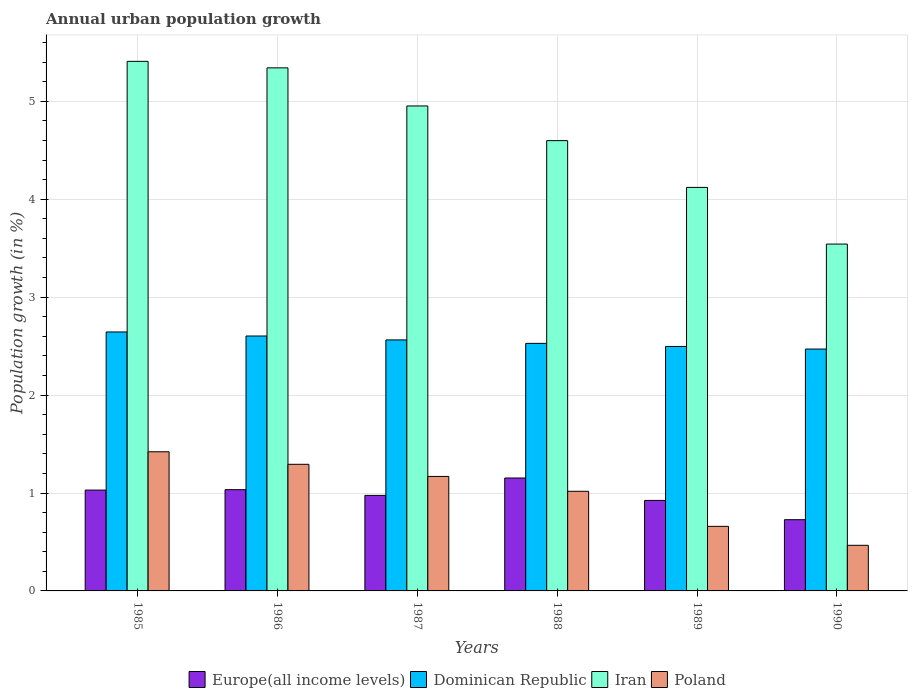How many different coloured bars are there?
Your answer should be compact. 4. How many groups of bars are there?
Your response must be concise. 6. Are the number of bars per tick equal to the number of legend labels?
Ensure brevity in your answer.  Yes. Are the number of bars on each tick of the X-axis equal?
Ensure brevity in your answer.  Yes. How many bars are there on the 3rd tick from the left?
Your answer should be compact. 4. What is the label of the 3rd group of bars from the left?
Make the answer very short. 1987. What is the percentage of urban population growth in Poland in 1988?
Your answer should be very brief. 1.02. Across all years, what is the maximum percentage of urban population growth in Poland?
Provide a short and direct response. 1.42. Across all years, what is the minimum percentage of urban population growth in Dominican Republic?
Make the answer very short. 2.47. In which year was the percentage of urban population growth in Iran minimum?
Provide a short and direct response. 1990. What is the total percentage of urban population growth in Poland in the graph?
Give a very brief answer. 6.03. What is the difference between the percentage of urban population growth in Dominican Republic in 1985 and that in 1990?
Ensure brevity in your answer.  0.17. What is the difference between the percentage of urban population growth in Poland in 1985 and the percentage of urban population growth in Iran in 1990?
Offer a terse response. -2.12. What is the average percentage of urban population growth in Dominican Republic per year?
Your response must be concise. 2.55. In the year 1989, what is the difference between the percentage of urban population growth in Dominican Republic and percentage of urban population growth in Europe(all income levels)?
Offer a very short reply. 1.57. In how many years, is the percentage of urban population growth in Europe(all income levels) greater than 2.4 %?
Your answer should be very brief. 0. What is the ratio of the percentage of urban population growth in Poland in 1987 to that in 1988?
Offer a very short reply. 1.15. Is the difference between the percentage of urban population growth in Dominican Republic in 1987 and 1990 greater than the difference between the percentage of urban population growth in Europe(all income levels) in 1987 and 1990?
Give a very brief answer. No. What is the difference between the highest and the second highest percentage of urban population growth in Iran?
Your answer should be compact. 0.07. What is the difference between the highest and the lowest percentage of urban population growth in Dominican Republic?
Ensure brevity in your answer.  0.17. Is the sum of the percentage of urban population growth in Iran in 1985 and 1989 greater than the maximum percentage of urban population growth in Europe(all income levels) across all years?
Keep it short and to the point. Yes. What does the 3rd bar from the right in 1989 represents?
Your answer should be compact. Dominican Republic. Is it the case that in every year, the sum of the percentage of urban population growth in Europe(all income levels) and percentage of urban population growth in Iran is greater than the percentage of urban population growth in Poland?
Keep it short and to the point. Yes. What is the difference between two consecutive major ticks on the Y-axis?
Offer a terse response. 1. How many legend labels are there?
Offer a terse response. 4. What is the title of the graph?
Provide a short and direct response. Annual urban population growth. Does "Tanzania" appear as one of the legend labels in the graph?
Offer a terse response. No. What is the label or title of the Y-axis?
Offer a terse response. Population growth (in %). What is the Population growth (in %) in Europe(all income levels) in 1985?
Keep it short and to the point. 1.03. What is the Population growth (in %) in Dominican Republic in 1985?
Your answer should be very brief. 2.64. What is the Population growth (in %) in Iran in 1985?
Your answer should be compact. 5.41. What is the Population growth (in %) of Poland in 1985?
Your answer should be compact. 1.42. What is the Population growth (in %) of Europe(all income levels) in 1986?
Offer a terse response. 1.03. What is the Population growth (in %) of Dominican Republic in 1986?
Your answer should be compact. 2.6. What is the Population growth (in %) of Iran in 1986?
Your response must be concise. 5.34. What is the Population growth (in %) of Poland in 1986?
Provide a succinct answer. 1.29. What is the Population growth (in %) in Europe(all income levels) in 1987?
Your response must be concise. 0.98. What is the Population growth (in %) in Dominican Republic in 1987?
Your answer should be compact. 2.56. What is the Population growth (in %) of Iran in 1987?
Give a very brief answer. 4.95. What is the Population growth (in %) in Poland in 1987?
Offer a terse response. 1.17. What is the Population growth (in %) in Europe(all income levels) in 1988?
Your answer should be compact. 1.15. What is the Population growth (in %) in Dominican Republic in 1988?
Ensure brevity in your answer.  2.53. What is the Population growth (in %) of Iran in 1988?
Ensure brevity in your answer.  4.6. What is the Population growth (in %) of Poland in 1988?
Your response must be concise. 1.02. What is the Population growth (in %) of Europe(all income levels) in 1989?
Ensure brevity in your answer.  0.92. What is the Population growth (in %) of Dominican Republic in 1989?
Make the answer very short. 2.5. What is the Population growth (in %) in Iran in 1989?
Your answer should be compact. 4.12. What is the Population growth (in %) in Poland in 1989?
Provide a succinct answer. 0.66. What is the Population growth (in %) in Europe(all income levels) in 1990?
Provide a succinct answer. 0.73. What is the Population growth (in %) in Dominican Republic in 1990?
Provide a succinct answer. 2.47. What is the Population growth (in %) of Iran in 1990?
Keep it short and to the point. 3.54. What is the Population growth (in %) of Poland in 1990?
Offer a terse response. 0.47. Across all years, what is the maximum Population growth (in %) of Europe(all income levels)?
Your response must be concise. 1.15. Across all years, what is the maximum Population growth (in %) in Dominican Republic?
Offer a terse response. 2.64. Across all years, what is the maximum Population growth (in %) of Iran?
Provide a short and direct response. 5.41. Across all years, what is the maximum Population growth (in %) of Poland?
Provide a short and direct response. 1.42. Across all years, what is the minimum Population growth (in %) of Europe(all income levels)?
Provide a short and direct response. 0.73. Across all years, what is the minimum Population growth (in %) in Dominican Republic?
Offer a very short reply. 2.47. Across all years, what is the minimum Population growth (in %) in Iran?
Provide a succinct answer. 3.54. Across all years, what is the minimum Population growth (in %) of Poland?
Make the answer very short. 0.47. What is the total Population growth (in %) in Europe(all income levels) in the graph?
Provide a succinct answer. 5.84. What is the total Population growth (in %) of Dominican Republic in the graph?
Your answer should be very brief. 15.31. What is the total Population growth (in %) of Iran in the graph?
Make the answer very short. 27.96. What is the total Population growth (in %) of Poland in the graph?
Give a very brief answer. 6.03. What is the difference between the Population growth (in %) of Europe(all income levels) in 1985 and that in 1986?
Your answer should be compact. -0. What is the difference between the Population growth (in %) of Dominican Republic in 1985 and that in 1986?
Offer a very short reply. 0.04. What is the difference between the Population growth (in %) in Iran in 1985 and that in 1986?
Make the answer very short. 0.07. What is the difference between the Population growth (in %) of Poland in 1985 and that in 1986?
Your answer should be compact. 0.13. What is the difference between the Population growth (in %) of Europe(all income levels) in 1985 and that in 1987?
Provide a succinct answer. 0.05. What is the difference between the Population growth (in %) of Dominican Republic in 1985 and that in 1987?
Give a very brief answer. 0.08. What is the difference between the Population growth (in %) in Iran in 1985 and that in 1987?
Offer a very short reply. 0.46. What is the difference between the Population growth (in %) in Poland in 1985 and that in 1987?
Ensure brevity in your answer.  0.25. What is the difference between the Population growth (in %) in Europe(all income levels) in 1985 and that in 1988?
Ensure brevity in your answer.  -0.12. What is the difference between the Population growth (in %) in Dominican Republic in 1985 and that in 1988?
Your answer should be compact. 0.12. What is the difference between the Population growth (in %) in Iran in 1985 and that in 1988?
Offer a terse response. 0.81. What is the difference between the Population growth (in %) in Poland in 1985 and that in 1988?
Your answer should be very brief. 0.4. What is the difference between the Population growth (in %) in Europe(all income levels) in 1985 and that in 1989?
Your answer should be very brief. 0.11. What is the difference between the Population growth (in %) of Dominican Republic in 1985 and that in 1989?
Your answer should be very brief. 0.15. What is the difference between the Population growth (in %) in Iran in 1985 and that in 1989?
Your answer should be very brief. 1.29. What is the difference between the Population growth (in %) in Poland in 1985 and that in 1989?
Make the answer very short. 0.76. What is the difference between the Population growth (in %) of Europe(all income levels) in 1985 and that in 1990?
Give a very brief answer. 0.3. What is the difference between the Population growth (in %) of Dominican Republic in 1985 and that in 1990?
Offer a terse response. 0.17. What is the difference between the Population growth (in %) of Iran in 1985 and that in 1990?
Your answer should be compact. 1.87. What is the difference between the Population growth (in %) in Poland in 1985 and that in 1990?
Keep it short and to the point. 0.96. What is the difference between the Population growth (in %) of Europe(all income levels) in 1986 and that in 1987?
Your answer should be very brief. 0.06. What is the difference between the Population growth (in %) of Dominican Republic in 1986 and that in 1987?
Give a very brief answer. 0.04. What is the difference between the Population growth (in %) of Iran in 1986 and that in 1987?
Provide a short and direct response. 0.39. What is the difference between the Population growth (in %) of Poland in 1986 and that in 1987?
Your response must be concise. 0.12. What is the difference between the Population growth (in %) of Europe(all income levels) in 1986 and that in 1988?
Your answer should be compact. -0.12. What is the difference between the Population growth (in %) in Dominican Republic in 1986 and that in 1988?
Your answer should be compact. 0.08. What is the difference between the Population growth (in %) of Iran in 1986 and that in 1988?
Provide a short and direct response. 0.74. What is the difference between the Population growth (in %) in Poland in 1986 and that in 1988?
Your response must be concise. 0.28. What is the difference between the Population growth (in %) in Europe(all income levels) in 1986 and that in 1989?
Offer a terse response. 0.11. What is the difference between the Population growth (in %) in Dominican Republic in 1986 and that in 1989?
Provide a short and direct response. 0.11. What is the difference between the Population growth (in %) of Iran in 1986 and that in 1989?
Offer a terse response. 1.22. What is the difference between the Population growth (in %) in Poland in 1986 and that in 1989?
Keep it short and to the point. 0.63. What is the difference between the Population growth (in %) of Europe(all income levels) in 1986 and that in 1990?
Your response must be concise. 0.31. What is the difference between the Population growth (in %) of Dominican Republic in 1986 and that in 1990?
Ensure brevity in your answer.  0.13. What is the difference between the Population growth (in %) of Iran in 1986 and that in 1990?
Offer a very short reply. 1.8. What is the difference between the Population growth (in %) of Poland in 1986 and that in 1990?
Your answer should be compact. 0.83. What is the difference between the Population growth (in %) of Europe(all income levels) in 1987 and that in 1988?
Your answer should be very brief. -0.18. What is the difference between the Population growth (in %) of Dominican Republic in 1987 and that in 1988?
Offer a terse response. 0.04. What is the difference between the Population growth (in %) in Iran in 1987 and that in 1988?
Your response must be concise. 0.35. What is the difference between the Population growth (in %) in Poland in 1987 and that in 1988?
Keep it short and to the point. 0.15. What is the difference between the Population growth (in %) of Europe(all income levels) in 1987 and that in 1989?
Provide a succinct answer. 0.05. What is the difference between the Population growth (in %) in Dominican Republic in 1987 and that in 1989?
Give a very brief answer. 0.07. What is the difference between the Population growth (in %) of Iran in 1987 and that in 1989?
Give a very brief answer. 0.83. What is the difference between the Population growth (in %) of Poland in 1987 and that in 1989?
Provide a succinct answer. 0.51. What is the difference between the Population growth (in %) in Europe(all income levels) in 1987 and that in 1990?
Make the answer very short. 0.25. What is the difference between the Population growth (in %) of Dominican Republic in 1987 and that in 1990?
Your answer should be compact. 0.09. What is the difference between the Population growth (in %) in Iran in 1987 and that in 1990?
Offer a very short reply. 1.41. What is the difference between the Population growth (in %) of Poland in 1987 and that in 1990?
Offer a very short reply. 0.7. What is the difference between the Population growth (in %) in Europe(all income levels) in 1988 and that in 1989?
Your answer should be compact. 0.23. What is the difference between the Population growth (in %) in Dominican Republic in 1988 and that in 1989?
Ensure brevity in your answer.  0.03. What is the difference between the Population growth (in %) of Iran in 1988 and that in 1989?
Make the answer very short. 0.48. What is the difference between the Population growth (in %) of Poland in 1988 and that in 1989?
Provide a short and direct response. 0.36. What is the difference between the Population growth (in %) in Europe(all income levels) in 1988 and that in 1990?
Offer a very short reply. 0.43. What is the difference between the Population growth (in %) in Dominican Republic in 1988 and that in 1990?
Your answer should be compact. 0.06. What is the difference between the Population growth (in %) in Iran in 1988 and that in 1990?
Offer a very short reply. 1.06. What is the difference between the Population growth (in %) in Poland in 1988 and that in 1990?
Offer a terse response. 0.55. What is the difference between the Population growth (in %) of Europe(all income levels) in 1989 and that in 1990?
Offer a very short reply. 0.2. What is the difference between the Population growth (in %) of Dominican Republic in 1989 and that in 1990?
Provide a succinct answer. 0.03. What is the difference between the Population growth (in %) in Iran in 1989 and that in 1990?
Your response must be concise. 0.58. What is the difference between the Population growth (in %) in Poland in 1989 and that in 1990?
Keep it short and to the point. 0.19. What is the difference between the Population growth (in %) of Europe(all income levels) in 1985 and the Population growth (in %) of Dominican Republic in 1986?
Give a very brief answer. -1.57. What is the difference between the Population growth (in %) of Europe(all income levels) in 1985 and the Population growth (in %) of Iran in 1986?
Offer a very short reply. -4.31. What is the difference between the Population growth (in %) in Europe(all income levels) in 1985 and the Population growth (in %) in Poland in 1986?
Your response must be concise. -0.26. What is the difference between the Population growth (in %) in Dominican Republic in 1985 and the Population growth (in %) in Iran in 1986?
Ensure brevity in your answer.  -2.7. What is the difference between the Population growth (in %) in Dominican Republic in 1985 and the Population growth (in %) in Poland in 1986?
Your answer should be very brief. 1.35. What is the difference between the Population growth (in %) in Iran in 1985 and the Population growth (in %) in Poland in 1986?
Your answer should be compact. 4.12. What is the difference between the Population growth (in %) in Europe(all income levels) in 1985 and the Population growth (in %) in Dominican Republic in 1987?
Provide a short and direct response. -1.53. What is the difference between the Population growth (in %) of Europe(all income levels) in 1985 and the Population growth (in %) of Iran in 1987?
Your answer should be compact. -3.92. What is the difference between the Population growth (in %) in Europe(all income levels) in 1985 and the Population growth (in %) in Poland in 1987?
Ensure brevity in your answer.  -0.14. What is the difference between the Population growth (in %) in Dominican Republic in 1985 and the Population growth (in %) in Iran in 1987?
Offer a terse response. -2.31. What is the difference between the Population growth (in %) of Dominican Republic in 1985 and the Population growth (in %) of Poland in 1987?
Offer a terse response. 1.48. What is the difference between the Population growth (in %) of Iran in 1985 and the Population growth (in %) of Poland in 1987?
Your answer should be compact. 4.24. What is the difference between the Population growth (in %) in Europe(all income levels) in 1985 and the Population growth (in %) in Dominican Republic in 1988?
Your answer should be compact. -1.5. What is the difference between the Population growth (in %) in Europe(all income levels) in 1985 and the Population growth (in %) in Iran in 1988?
Ensure brevity in your answer.  -3.57. What is the difference between the Population growth (in %) of Europe(all income levels) in 1985 and the Population growth (in %) of Poland in 1988?
Offer a very short reply. 0.01. What is the difference between the Population growth (in %) of Dominican Republic in 1985 and the Population growth (in %) of Iran in 1988?
Give a very brief answer. -1.95. What is the difference between the Population growth (in %) in Dominican Republic in 1985 and the Population growth (in %) in Poland in 1988?
Offer a terse response. 1.63. What is the difference between the Population growth (in %) in Iran in 1985 and the Population growth (in %) in Poland in 1988?
Provide a short and direct response. 4.39. What is the difference between the Population growth (in %) of Europe(all income levels) in 1985 and the Population growth (in %) of Dominican Republic in 1989?
Offer a terse response. -1.47. What is the difference between the Population growth (in %) in Europe(all income levels) in 1985 and the Population growth (in %) in Iran in 1989?
Keep it short and to the point. -3.09. What is the difference between the Population growth (in %) of Europe(all income levels) in 1985 and the Population growth (in %) of Poland in 1989?
Keep it short and to the point. 0.37. What is the difference between the Population growth (in %) in Dominican Republic in 1985 and the Population growth (in %) in Iran in 1989?
Make the answer very short. -1.48. What is the difference between the Population growth (in %) in Dominican Republic in 1985 and the Population growth (in %) in Poland in 1989?
Provide a short and direct response. 1.99. What is the difference between the Population growth (in %) in Iran in 1985 and the Population growth (in %) in Poland in 1989?
Ensure brevity in your answer.  4.75. What is the difference between the Population growth (in %) in Europe(all income levels) in 1985 and the Population growth (in %) in Dominican Republic in 1990?
Your answer should be compact. -1.44. What is the difference between the Population growth (in %) in Europe(all income levels) in 1985 and the Population growth (in %) in Iran in 1990?
Offer a terse response. -2.51. What is the difference between the Population growth (in %) in Europe(all income levels) in 1985 and the Population growth (in %) in Poland in 1990?
Provide a short and direct response. 0.56. What is the difference between the Population growth (in %) in Dominican Republic in 1985 and the Population growth (in %) in Iran in 1990?
Your response must be concise. -0.9. What is the difference between the Population growth (in %) in Dominican Republic in 1985 and the Population growth (in %) in Poland in 1990?
Ensure brevity in your answer.  2.18. What is the difference between the Population growth (in %) of Iran in 1985 and the Population growth (in %) of Poland in 1990?
Provide a short and direct response. 4.94. What is the difference between the Population growth (in %) in Europe(all income levels) in 1986 and the Population growth (in %) in Dominican Republic in 1987?
Provide a succinct answer. -1.53. What is the difference between the Population growth (in %) in Europe(all income levels) in 1986 and the Population growth (in %) in Iran in 1987?
Your response must be concise. -3.92. What is the difference between the Population growth (in %) in Europe(all income levels) in 1986 and the Population growth (in %) in Poland in 1987?
Your response must be concise. -0.14. What is the difference between the Population growth (in %) in Dominican Republic in 1986 and the Population growth (in %) in Iran in 1987?
Your answer should be very brief. -2.35. What is the difference between the Population growth (in %) in Dominican Republic in 1986 and the Population growth (in %) in Poland in 1987?
Provide a succinct answer. 1.43. What is the difference between the Population growth (in %) in Iran in 1986 and the Population growth (in %) in Poland in 1987?
Keep it short and to the point. 4.17. What is the difference between the Population growth (in %) in Europe(all income levels) in 1986 and the Population growth (in %) in Dominican Republic in 1988?
Keep it short and to the point. -1.49. What is the difference between the Population growth (in %) in Europe(all income levels) in 1986 and the Population growth (in %) in Iran in 1988?
Make the answer very short. -3.56. What is the difference between the Population growth (in %) of Europe(all income levels) in 1986 and the Population growth (in %) of Poland in 1988?
Provide a short and direct response. 0.02. What is the difference between the Population growth (in %) of Dominican Republic in 1986 and the Population growth (in %) of Iran in 1988?
Your answer should be very brief. -2. What is the difference between the Population growth (in %) in Dominican Republic in 1986 and the Population growth (in %) in Poland in 1988?
Your response must be concise. 1.59. What is the difference between the Population growth (in %) of Iran in 1986 and the Population growth (in %) of Poland in 1988?
Your answer should be compact. 4.32. What is the difference between the Population growth (in %) of Europe(all income levels) in 1986 and the Population growth (in %) of Dominican Republic in 1989?
Your answer should be very brief. -1.46. What is the difference between the Population growth (in %) of Europe(all income levels) in 1986 and the Population growth (in %) of Iran in 1989?
Your answer should be compact. -3.09. What is the difference between the Population growth (in %) in Europe(all income levels) in 1986 and the Population growth (in %) in Poland in 1989?
Provide a succinct answer. 0.37. What is the difference between the Population growth (in %) in Dominican Republic in 1986 and the Population growth (in %) in Iran in 1989?
Ensure brevity in your answer.  -1.52. What is the difference between the Population growth (in %) in Dominican Republic in 1986 and the Population growth (in %) in Poland in 1989?
Make the answer very short. 1.94. What is the difference between the Population growth (in %) of Iran in 1986 and the Population growth (in %) of Poland in 1989?
Keep it short and to the point. 4.68. What is the difference between the Population growth (in %) of Europe(all income levels) in 1986 and the Population growth (in %) of Dominican Republic in 1990?
Give a very brief answer. -1.44. What is the difference between the Population growth (in %) of Europe(all income levels) in 1986 and the Population growth (in %) of Iran in 1990?
Your answer should be compact. -2.51. What is the difference between the Population growth (in %) of Europe(all income levels) in 1986 and the Population growth (in %) of Poland in 1990?
Offer a terse response. 0.57. What is the difference between the Population growth (in %) in Dominican Republic in 1986 and the Population growth (in %) in Iran in 1990?
Make the answer very short. -0.94. What is the difference between the Population growth (in %) in Dominican Republic in 1986 and the Population growth (in %) in Poland in 1990?
Keep it short and to the point. 2.14. What is the difference between the Population growth (in %) of Iran in 1986 and the Population growth (in %) of Poland in 1990?
Provide a succinct answer. 4.88. What is the difference between the Population growth (in %) in Europe(all income levels) in 1987 and the Population growth (in %) in Dominican Republic in 1988?
Provide a succinct answer. -1.55. What is the difference between the Population growth (in %) in Europe(all income levels) in 1987 and the Population growth (in %) in Iran in 1988?
Make the answer very short. -3.62. What is the difference between the Population growth (in %) in Europe(all income levels) in 1987 and the Population growth (in %) in Poland in 1988?
Keep it short and to the point. -0.04. What is the difference between the Population growth (in %) in Dominican Republic in 1987 and the Population growth (in %) in Iran in 1988?
Give a very brief answer. -2.04. What is the difference between the Population growth (in %) in Dominican Republic in 1987 and the Population growth (in %) in Poland in 1988?
Your answer should be compact. 1.55. What is the difference between the Population growth (in %) in Iran in 1987 and the Population growth (in %) in Poland in 1988?
Your answer should be compact. 3.94. What is the difference between the Population growth (in %) of Europe(all income levels) in 1987 and the Population growth (in %) of Dominican Republic in 1989?
Your answer should be very brief. -1.52. What is the difference between the Population growth (in %) of Europe(all income levels) in 1987 and the Population growth (in %) of Iran in 1989?
Offer a very short reply. -3.15. What is the difference between the Population growth (in %) in Europe(all income levels) in 1987 and the Population growth (in %) in Poland in 1989?
Make the answer very short. 0.32. What is the difference between the Population growth (in %) in Dominican Republic in 1987 and the Population growth (in %) in Iran in 1989?
Make the answer very short. -1.56. What is the difference between the Population growth (in %) in Dominican Republic in 1987 and the Population growth (in %) in Poland in 1989?
Offer a very short reply. 1.9. What is the difference between the Population growth (in %) of Iran in 1987 and the Population growth (in %) of Poland in 1989?
Your answer should be compact. 4.29. What is the difference between the Population growth (in %) in Europe(all income levels) in 1987 and the Population growth (in %) in Dominican Republic in 1990?
Ensure brevity in your answer.  -1.49. What is the difference between the Population growth (in %) in Europe(all income levels) in 1987 and the Population growth (in %) in Iran in 1990?
Offer a terse response. -2.57. What is the difference between the Population growth (in %) in Europe(all income levels) in 1987 and the Population growth (in %) in Poland in 1990?
Offer a terse response. 0.51. What is the difference between the Population growth (in %) of Dominican Republic in 1987 and the Population growth (in %) of Iran in 1990?
Provide a short and direct response. -0.98. What is the difference between the Population growth (in %) of Dominican Republic in 1987 and the Population growth (in %) of Poland in 1990?
Provide a short and direct response. 2.1. What is the difference between the Population growth (in %) in Iran in 1987 and the Population growth (in %) in Poland in 1990?
Keep it short and to the point. 4.49. What is the difference between the Population growth (in %) in Europe(all income levels) in 1988 and the Population growth (in %) in Dominican Republic in 1989?
Make the answer very short. -1.34. What is the difference between the Population growth (in %) of Europe(all income levels) in 1988 and the Population growth (in %) of Iran in 1989?
Your response must be concise. -2.97. What is the difference between the Population growth (in %) in Europe(all income levels) in 1988 and the Population growth (in %) in Poland in 1989?
Provide a short and direct response. 0.49. What is the difference between the Population growth (in %) of Dominican Republic in 1988 and the Population growth (in %) of Iran in 1989?
Your answer should be compact. -1.59. What is the difference between the Population growth (in %) in Dominican Republic in 1988 and the Population growth (in %) in Poland in 1989?
Provide a short and direct response. 1.87. What is the difference between the Population growth (in %) in Iran in 1988 and the Population growth (in %) in Poland in 1989?
Your answer should be compact. 3.94. What is the difference between the Population growth (in %) of Europe(all income levels) in 1988 and the Population growth (in %) of Dominican Republic in 1990?
Give a very brief answer. -1.32. What is the difference between the Population growth (in %) of Europe(all income levels) in 1988 and the Population growth (in %) of Iran in 1990?
Provide a succinct answer. -2.39. What is the difference between the Population growth (in %) in Europe(all income levels) in 1988 and the Population growth (in %) in Poland in 1990?
Your answer should be very brief. 0.69. What is the difference between the Population growth (in %) in Dominican Republic in 1988 and the Population growth (in %) in Iran in 1990?
Your answer should be very brief. -1.01. What is the difference between the Population growth (in %) in Dominican Republic in 1988 and the Population growth (in %) in Poland in 1990?
Offer a very short reply. 2.06. What is the difference between the Population growth (in %) of Iran in 1988 and the Population growth (in %) of Poland in 1990?
Your response must be concise. 4.13. What is the difference between the Population growth (in %) in Europe(all income levels) in 1989 and the Population growth (in %) in Dominican Republic in 1990?
Give a very brief answer. -1.55. What is the difference between the Population growth (in %) of Europe(all income levels) in 1989 and the Population growth (in %) of Iran in 1990?
Your answer should be compact. -2.62. What is the difference between the Population growth (in %) of Europe(all income levels) in 1989 and the Population growth (in %) of Poland in 1990?
Your answer should be compact. 0.46. What is the difference between the Population growth (in %) in Dominican Republic in 1989 and the Population growth (in %) in Iran in 1990?
Your answer should be compact. -1.05. What is the difference between the Population growth (in %) of Dominican Republic in 1989 and the Population growth (in %) of Poland in 1990?
Offer a terse response. 2.03. What is the difference between the Population growth (in %) of Iran in 1989 and the Population growth (in %) of Poland in 1990?
Offer a terse response. 3.66. What is the average Population growth (in %) in Europe(all income levels) per year?
Make the answer very short. 0.97. What is the average Population growth (in %) of Dominican Republic per year?
Your response must be concise. 2.55. What is the average Population growth (in %) of Iran per year?
Ensure brevity in your answer.  4.66. In the year 1985, what is the difference between the Population growth (in %) of Europe(all income levels) and Population growth (in %) of Dominican Republic?
Offer a terse response. -1.61. In the year 1985, what is the difference between the Population growth (in %) in Europe(all income levels) and Population growth (in %) in Iran?
Offer a very short reply. -4.38. In the year 1985, what is the difference between the Population growth (in %) of Europe(all income levels) and Population growth (in %) of Poland?
Offer a terse response. -0.39. In the year 1985, what is the difference between the Population growth (in %) of Dominican Republic and Population growth (in %) of Iran?
Ensure brevity in your answer.  -2.76. In the year 1985, what is the difference between the Population growth (in %) in Dominican Republic and Population growth (in %) in Poland?
Offer a very short reply. 1.22. In the year 1985, what is the difference between the Population growth (in %) in Iran and Population growth (in %) in Poland?
Ensure brevity in your answer.  3.99. In the year 1986, what is the difference between the Population growth (in %) of Europe(all income levels) and Population growth (in %) of Dominican Republic?
Offer a very short reply. -1.57. In the year 1986, what is the difference between the Population growth (in %) of Europe(all income levels) and Population growth (in %) of Iran?
Ensure brevity in your answer.  -4.31. In the year 1986, what is the difference between the Population growth (in %) of Europe(all income levels) and Population growth (in %) of Poland?
Offer a very short reply. -0.26. In the year 1986, what is the difference between the Population growth (in %) in Dominican Republic and Population growth (in %) in Iran?
Offer a terse response. -2.74. In the year 1986, what is the difference between the Population growth (in %) of Dominican Republic and Population growth (in %) of Poland?
Provide a short and direct response. 1.31. In the year 1986, what is the difference between the Population growth (in %) in Iran and Population growth (in %) in Poland?
Provide a succinct answer. 4.05. In the year 1987, what is the difference between the Population growth (in %) of Europe(all income levels) and Population growth (in %) of Dominican Republic?
Your answer should be very brief. -1.59. In the year 1987, what is the difference between the Population growth (in %) in Europe(all income levels) and Population growth (in %) in Iran?
Ensure brevity in your answer.  -3.98. In the year 1987, what is the difference between the Population growth (in %) in Europe(all income levels) and Population growth (in %) in Poland?
Offer a terse response. -0.19. In the year 1987, what is the difference between the Population growth (in %) in Dominican Republic and Population growth (in %) in Iran?
Ensure brevity in your answer.  -2.39. In the year 1987, what is the difference between the Population growth (in %) of Dominican Republic and Population growth (in %) of Poland?
Provide a succinct answer. 1.39. In the year 1987, what is the difference between the Population growth (in %) of Iran and Population growth (in %) of Poland?
Make the answer very short. 3.78. In the year 1988, what is the difference between the Population growth (in %) in Europe(all income levels) and Population growth (in %) in Dominican Republic?
Keep it short and to the point. -1.38. In the year 1988, what is the difference between the Population growth (in %) in Europe(all income levels) and Population growth (in %) in Iran?
Offer a very short reply. -3.45. In the year 1988, what is the difference between the Population growth (in %) in Europe(all income levels) and Population growth (in %) in Poland?
Provide a succinct answer. 0.14. In the year 1988, what is the difference between the Population growth (in %) of Dominican Republic and Population growth (in %) of Iran?
Make the answer very short. -2.07. In the year 1988, what is the difference between the Population growth (in %) of Dominican Republic and Population growth (in %) of Poland?
Your response must be concise. 1.51. In the year 1988, what is the difference between the Population growth (in %) in Iran and Population growth (in %) in Poland?
Make the answer very short. 3.58. In the year 1989, what is the difference between the Population growth (in %) of Europe(all income levels) and Population growth (in %) of Dominican Republic?
Provide a succinct answer. -1.57. In the year 1989, what is the difference between the Population growth (in %) in Europe(all income levels) and Population growth (in %) in Iran?
Your answer should be very brief. -3.2. In the year 1989, what is the difference between the Population growth (in %) of Europe(all income levels) and Population growth (in %) of Poland?
Your answer should be very brief. 0.27. In the year 1989, what is the difference between the Population growth (in %) in Dominican Republic and Population growth (in %) in Iran?
Make the answer very short. -1.62. In the year 1989, what is the difference between the Population growth (in %) of Dominican Republic and Population growth (in %) of Poland?
Offer a very short reply. 1.84. In the year 1989, what is the difference between the Population growth (in %) of Iran and Population growth (in %) of Poland?
Ensure brevity in your answer.  3.46. In the year 1990, what is the difference between the Population growth (in %) in Europe(all income levels) and Population growth (in %) in Dominican Republic?
Your answer should be very brief. -1.74. In the year 1990, what is the difference between the Population growth (in %) of Europe(all income levels) and Population growth (in %) of Iran?
Provide a succinct answer. -2.81. In the year 1990, what is the difference between the Population growth (in %) of Europe(all income levels) and Population growth (in %) of Poland?
Your answer should be compact. 0.26. In the year 1990, what is the difference between the Population growth (in %) in Dominican Republic and Population growth (in %) in Iran?
Ensure brevity in your answer.  -1.07. In the year 1990, what is the difference between the Population growth (in %) of Dominican Republic and Population growth (in %) of Poland?
Offer a very short reply. 2. In the year 1990, what is the difference between the Population growth (in %) of Iran and Population growth (in %) of Poland?
Offer a terse response. 3.08. What is the ratio of the Population growth (in %) of Dominican Republic in 1985 to that in 1986?
Give a very brief answer. 1.02. What is the ratio of the Population growth (in %) of Iran in 1985 to that in 1986?
Offer a terse response. 1.01. What is the ratio of the Population growth (in %) of Poland in 1985 to that in 1986?
Provide a short and direct response. 1.1. What is the ratio of the Population growth (in %) in Europe(all income levels) in 1985 to that in 1987?
Give a very brief answer. 1.06. What is the ratio of the Population growth (in %) in Dominican Republic in 1985 to that in 1987?
Provide a short and direct response. 1.03. What is the ratio of the Population growth (in %) in Iran in 1985 to that in 1987?
Provide a short and direct response. 1.09. What is the ratio of the Population growth (in %) in Poland in 1985 to that in 1987?
Ensure brevity in your answer.  1.22. What is the ratio of the Population growth (in %) of Europe(all income levels) in 1985 to that in 1988?
Make the answer very short. 0.89. What is the ratio of the Population growth (in %) of Dominican Republic in 1985 to that in 1988?
Your response must be concise. 1.05. What is the ratio of the Population growth (in %) in Iran in 1985 to that in 1988?
Your response must be concise. 1.18. What is the ratio of the Population growth (in %) of Poland in 1985 to that in 1988?
Keep it short and to the point. 1.4. What is the ratio of the Population growth (in %) in Europe(all income levels) in 1985 to that in 1989?
Your answer should be very brief. 1.11. What is the ratio of the Population growth (in %) of Dominican Republic in 1985 to that in 1989?
Your answer should be compact. 1.06. What is the ratio of the Population growth (in %) of Iran in 1985 to that in 1989?
Your answer should be compact. 1.31. What is the ratio of the Population growth (in %) of Poland in 1985 to that in 1989?
Your answer should be very brief. 2.16. What is the ratio of the Population growth (in %) in Europe(all income levels) in 1985 to that in 1990?
Give a very brief answer. 1.42. What is the ratio of the Population growth (in %) of Dominican Republic in 1985 to that in 1990?
Offer a very short reply. 1.07. What is the ratio of the Population growth (in %) in Iran in 1985 to that in 1990?
Offer a very short reply. 1.53. What is the ratio of the Population growth (in %) of Poland in 1985 to that in 1990?
Your answer should be very brief. 3.05. What is the ratio of the Population growth (in %) of Europe(all income levels) in 1986 to that in 1987?
Provide a succinct answer. 1.06. What is the ratio of the Population growth (in %) of Dominican Republic in 1986 to that in 1987?
Provide a short and direct response. 1.02. What is the ratio of the Population growth (in %) of Iran in 1986 to that in 1987?
Provide a succinct answer. 1.08. What is the ratio of the Population growth (in %) in Poland in 1986 to that in 1987?
Your answer should be compact. 1.11. What is the ratio of the Population growth (in %) of Europe(all income levels) in 1986 to that in 1988?
Ensure brevity in your answer.  0.9. What is the ratio of the Population growth (in %) of Dominican Republic in 1986 to that in 1988?
Offer a terse response. 1.03. What is the ratio of the Population growth (in %) of Iran in 1986 to that in 1988?
Offer a very short reply. 1.16. What is the ratio of the Population growth (in %) of Poland in 1986 to that in 1988?
Keep it short and to the point. 1.27. What is the ratio of the Population growth (in %) of Europe(all income levels) in 1986 to that in 1989?
Keep it short and to the point. 1.12. What is the ratio of the Population growth (in %) in Dominican Republic in 1986 to that in 1989?
Your answer should be very brief. 1.04. What is the ratio of the Population growth (in %) in Iran in 1986 to that in 1989?
Ensure brevity in your answer.  1.3. What is the ratio of the Population growth (in %) of Poland in 1986 to that in 1989?
Make the answer very short. 1.96. What is the ratio of the Population growth (in %) in Europe(all income levels) in 1986 to that in 1990?
Your answer should be compact. 1.42. What is the ratio of the Population growth (in %) in Dominican Republic in 1986 to that in 1990?
Your answer should be very brief. 1.05. What is the ratio of the Population growth (in %) in Iran in 1986 to that in 1990?
Provide a short and direct response. 1.51. What is the ratio of the Population growth (in %) of Poland in 1986 to that in 1990?
Provide a succinct answer. 2.78. What is the ratio of the Population growth (in %) of Europe(all income levels) in 1987 to that in 1988?
Ensure brevity in your answer.  0.85. What is the ratio of the Population growth (in %) of Dominican Republic in 1987 to that in 1988?
Provide a short and direct response. 1.01. What is the ratio of the Population growth (in %) in Iran in 1987 to that in 1988?
Ensure brevity in your answer.  1.08. What is the ratio of the Population growth (in %) of Poland in 1987 to that in 1988?
Your answer should be compact. 1.15. What is the ratio of the Population growth (in %) of Europe(all income levels) in 1987 to that in 1989?
Your answer should be compact. 1.06. What is the ratio of the Population growth (in %) of Dominican Republic in 1987 to that in 1989?
Keep it short and to the point. 1.03. What is the ratio of the Population growth (in %) in Iran in 1987 to that in 1989?
Your response must be concise. 1.2. What is the ratio of the Population growth (in %) of Poland in 1987 to that in 1989?
Provide a short and direct response. 1.77. What is the ratio of the Population growth (in %) in Europe(all income levels) in 1987 to that in 1990?
Your response must be concise. 1.34. What is the ratio of the Population growth (in %) of Dominican Republic in 1987 to that in 1990?
Provide a succinct answer. 1.04. What is the ratio of the Population growth (in %) of Iran in 1987 to that in 1990?
Keep it short and to the point. 1.4. What is the ratio of the Population growth (in %) of Poland in 1987 to that in 1990?
Make the answer very short. 2.51. What is the ratio of the Population growth (in %) in Europe(all income levels) in 1988 to that in 1989?
Your answer should be very brief. 1.25. What is the ratio of the Population growth (in %) of Dominican Republic in 1988 to that in 1989?
Provide a succinct answer. 1.01. What is the ratio of the Population growth (in %) of Iran in 1988 to that in 1989?
Provide a succinct answer. 1.12. What is the ratio of the Population growth (in %) of Poland in 1988 to that in 1989?
Your answer should be very brief. 1.54. What is the ratio of the Population growth (in %) in Europe(all income levels) in 1988 to that in 1990?
Offer a very short reply. 1.59. What is the ratio of the Population growth (in %) of Dominican Republic in 1988 to that in 1990?
Give a very brief answer. 1.02. What is the ratio of the Population growth (in %) in Iran in 1988 to that in 1990?
Your response must be concise. 1.3. What is the ratio of the Population growth (in %) of Poland in 1988 to that in 1990?
Provide a short and direct response. 2.18. What is the ratio of the Population growth (in %) of Europe(all income levels) in 1989 to that in 1990?
Provide a short and direct response. 1.27. What is the ratio of the Population growth (in %) of Dominican Republic in 1989 to that in 1990?
Make the answer very short. 1.01. What is the ratio of the Population growth (in %) in Iran in 1989 to that in 1990?
Make the answer very short. 1.16. What is the ratio of the Population growth (in %) in Poland in 1989 to that in 1990?
Your response must be concise. 1.42. What is the difference between the highest and the second highest Population growth (in %) of Europe(all income levels)?
Ensure brevity in your answer.  0.12. What is the difference between the highest and the second highest Population growth (in %) in Dominican Republic?
Provide a short and direct response. 0.04. What is the difference between the highest and the second highest Population growth (in %) in Iran?
Keep it short and to the point. 0.07. What is the difference between the highest and the second highest Population growth (in %) in Poland?
Keep it short and to the point. 0.13. What is the difference between the highest and the lowest Population growth (in %) of Europe(all income levels)?
Offer a terse response. 0.43. What is the difference between the highest and the lowest Population growth (in %) in Dominican Republic?
Keep it short and to the point. 0.17. What is the difference between the highest and the lowest Population growth (in %) of Iran?
Give a very brief answer. 1.87. What is the difference between the highest and the lowest Population growth (in %) in Poland?
Provide a succinct answer. 0.96. 